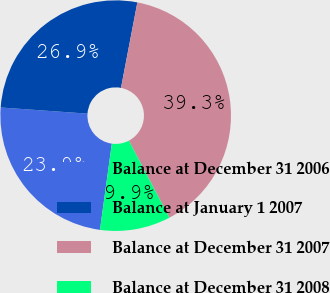Convert chart. <chart><loc_0><loc_0><loc_500><loc_500><pie_chart><fcel>Balance at December 31 2006<fcel>Balance at January 1 2007<fcel>Balance at December 31 2007<fcel>Balance at December 31 2008<nl><fcel>23.95%<fcel>26.89%<fcel>39.28%<fcel>9.89%<nl></chart> 